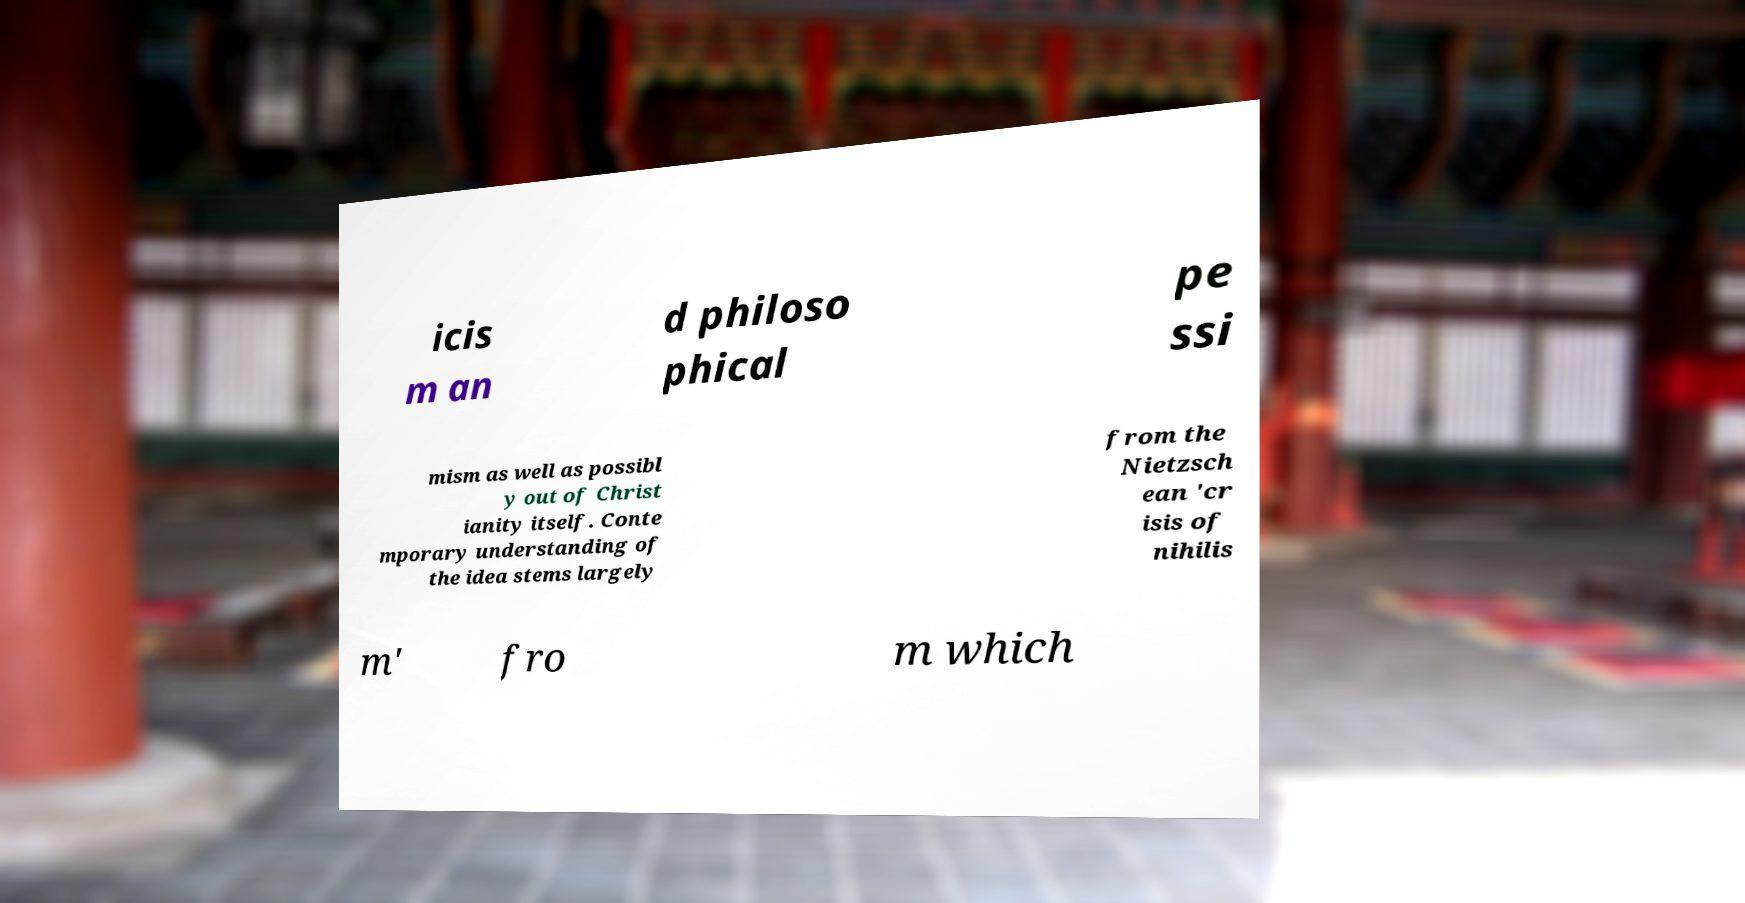Could you extract and type out the text from this image? icis m an d philoso phical pe ssi mism as well as possibl y out of Christ ianity itself. Conte mporary understanding of the idea stems largely from the Nietzsch ean 'cr isis of nihilis m' fro m which 